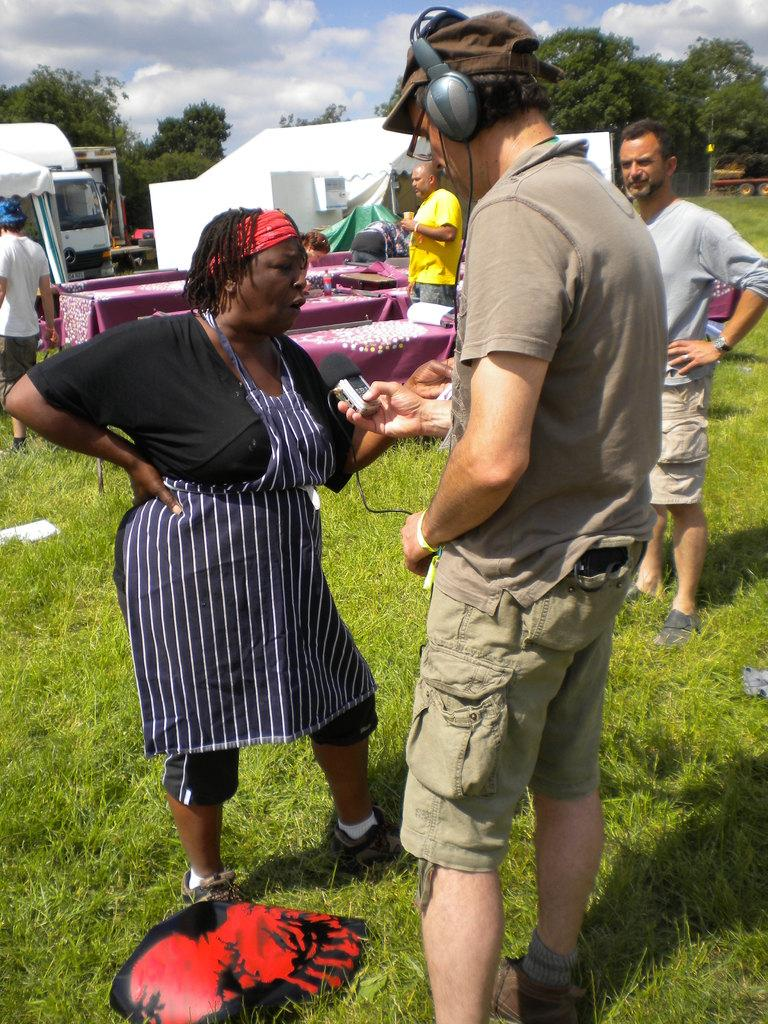How many people are standing on the grass in the image? There are five persons standing on the grass in the image. What else can be seen in the image besides the people? There are tablecloths, a bottle, vehicles, tents, trees, and the sky visible in the image. Can you describe the background of the image? The background of the image includes trees and the sky, which has clouds. What might be used for covering tables in the image? Tablecloths are present in the image for covering tables. What type of boot can be seen in the image? There is no boot present in the image. What is the curve of the shock in the image? There is no shock or curve present in the image. 